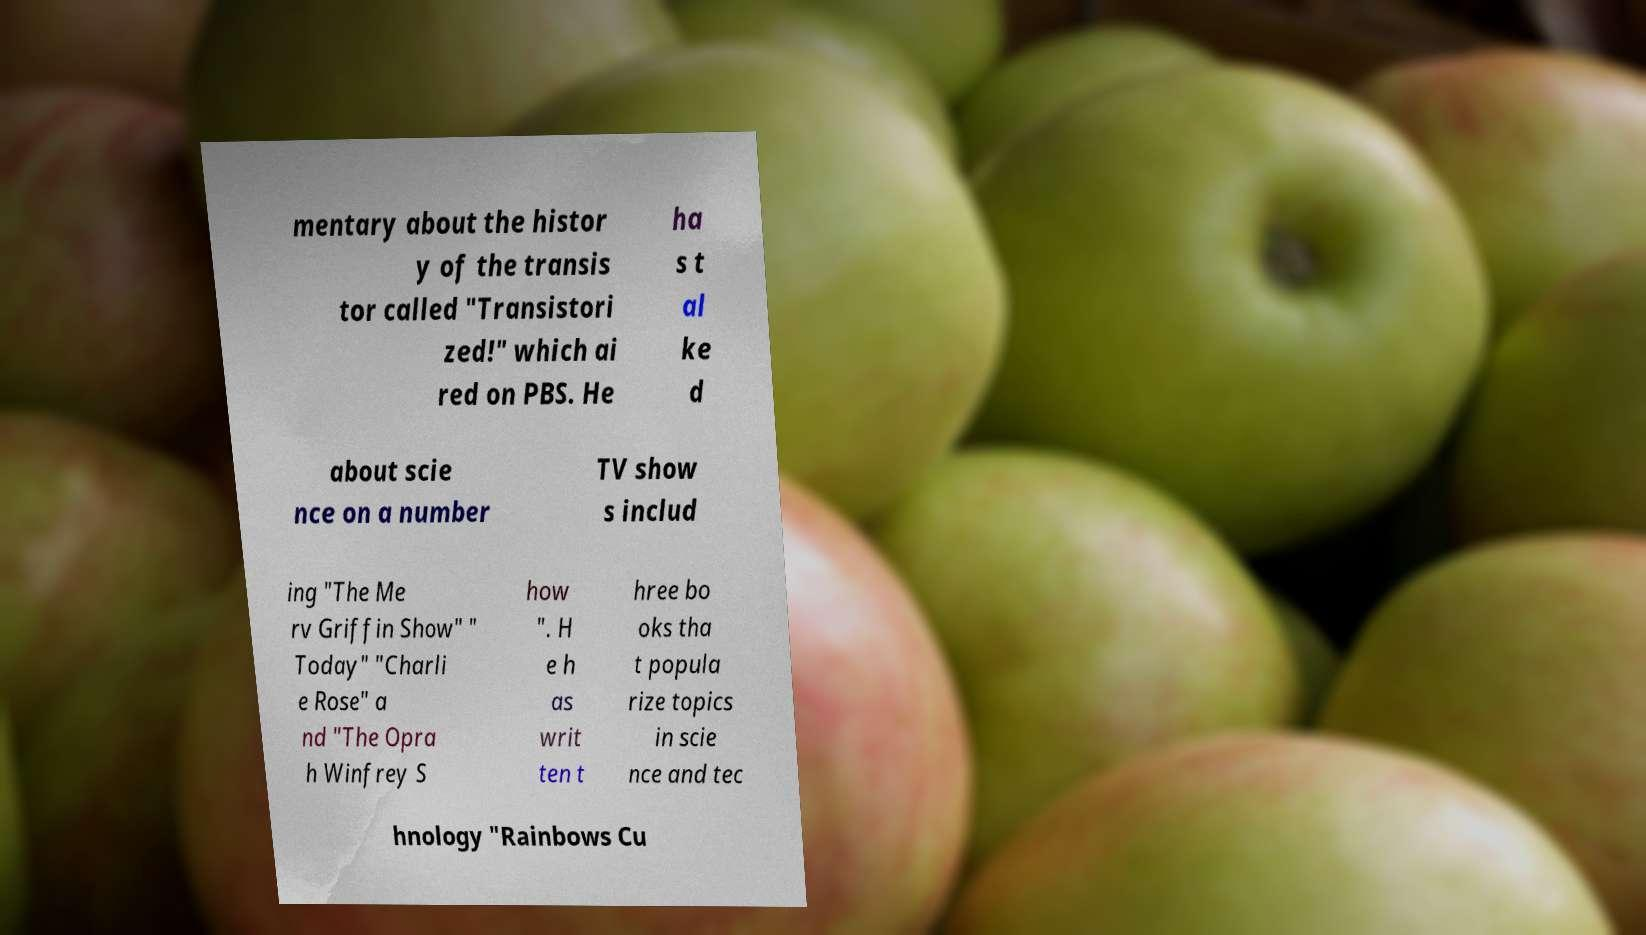Could you assist in decoding the text presented in this image and type it out clearly? mentary about the histor y of the transis tor called "Transistori zed!" which ai red on PBS. He ha s t al ke d about scie nce on a number TV show s includ ing "The Me rv Griffin Show" " Today" "Charli e Rose" a nd "The Opra h Winfrey S how ". H e h as writ ten t hree bo oks tha t popula rize topics in scie nce and tec hnology "Rainbows Cu 